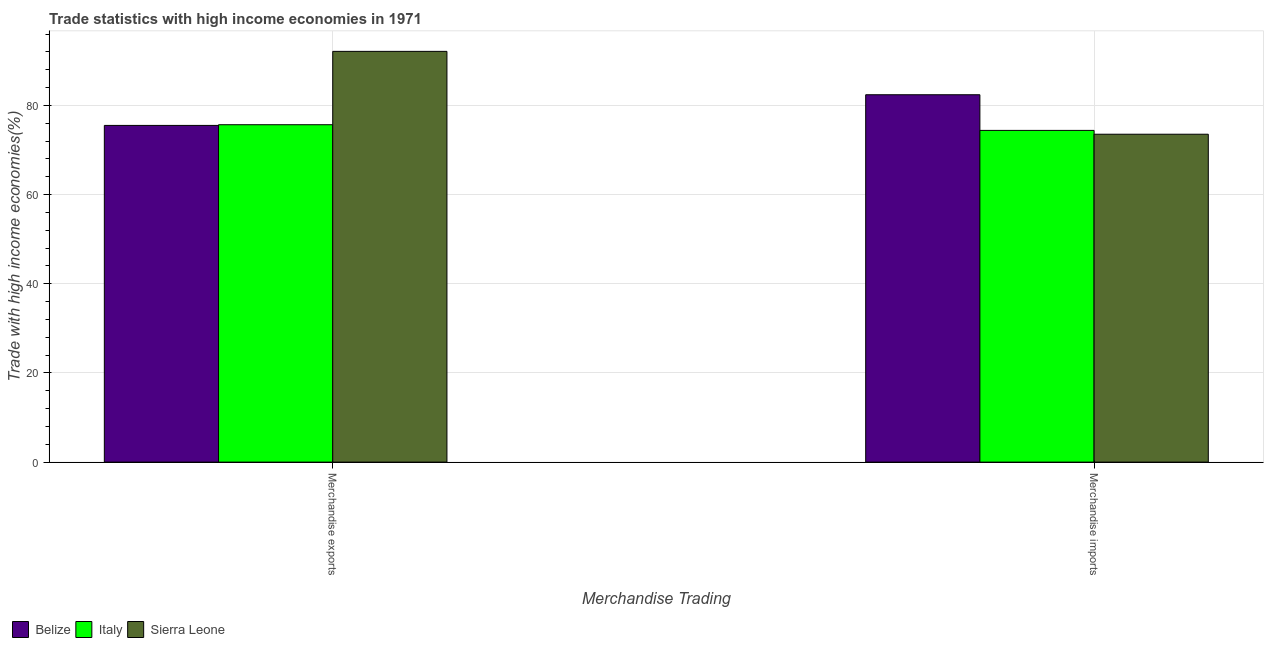Are the number of bars per tick equal to the number of legend labels?
Keep it short and to the point. Yes. How many bars are there on the 1st tick from the left?
Offer a terse response. 3. What is the label of the 2nd group of bars from the left?
Keep it short and to the point. Merchandise imports. What is the merchandise imports in Belize?
Your answer should be very brief. 82.4. Across all countries, what is the maximum merchandise imports?
Offer a very short reply. 82.4. Across all countries, what is the minimum merchandise exports?
Provide a succinct answer. 75.53. In which country was the merchandise imports maximum?
Offer a terse response. Belize. In which country was the merchandise imports minimum?
Provide a short and direct response. Sierra Leone. What is the total merchandise exports in the graph?
Ensure brevity in your answer.  243.34. What is the difference between the merchandise imports in Belize and that in Italy?
Your answer should be compact. 8. What is the difference between the merchandise exports in Italy and the merchandise imports in Sierra Leone?
Give a very brief answer. 2.13. What is the average merchandise imports per country?
Offer a very short reply. 76.79. What is the difference between the merchandise exports and merchandise imports in Sierra Leone?
Keep it short and to the point. 18.59. What is the ratio of the merchandise imports in Sierra Leone to that in Belize?
Your answer should be very brief. 0.89. Is the merchandise imports in Sierra Leone less than that in Belize?
Provide a succinct answer. Yes. In how many countries, is the merchandise exports greater than the average merchandise exports taken over all countries?
Your response must be concise. 1. What does the 1st bar from the left in Merchandise imports represents?
Provide a short and direct response. Belize. What does the 3rd bar from the right in Merchandise imports represents?
Keep it short and to the point. Belize. How many bars are there?
Give a very brief answer. 6. Where does the legend appear in the graph?
Your answer should be very brief. Bottom left. How are the legend labels stacked?
Make the answer very short. Horizontal. What is the title of the graph?
Ensure brevity in your answer.  Trade statistics with high income economies in 1971. Does "Andorra" appear as one of the legend labels in the graph?
Your answer should be very brief. No. What is the label or title of the X-axis?
Offer a very short reply. Merchandise Trading. What is the label or title of the Y-axis?
Your answer should be compact. Trade with high income economies(%). What is the Trade with high income economies(%) in Belize in Merchandise exports?
Make the answer very short. 75.53. What is the Trade with high income economies(%) of Italy in Merchandise exports?
Your answer should be compact. 75.68. What is the Trade with high income economies(%) in Sierra Leone in Merchandise exports?
Your answer should be compact. 92.14. What is the Trade with high income economies(%) of Belize in Merchandise imports?
Your answer should be very brief. 82.4. What is the Trade with high income economies(%) in Italy in Merchandise imports?
Offer a very short reply. 74.41. What is the Trade with high income economies(%) in Sierra Leone in Merchandise imports?
Make the answer very short. 73.55. Across all Merchandise Trading, what is the maximum Trade with high income economies(%) in Belize?
Give a very brief answer. 82.4. Across all Merchandise Trading, what is the maximum Trade with high income economies(%) in Italy?
Make the answer very short. 75.68. Across all Merchandise Trading, what is the maximum Trade with high income economies(%) of Sierra Leone?
Offer a terse response. 92.14. Across all Merchandise Trading, what is the minimum Trade with high income economies(%) in Belize?
Your response must be concise. 75.53. Across all Merchandise Trading, what is the minimum Trade with high income economies(%) in Italy?
Your response must be concise. 74.41. Across all Merchandise Trading, what is the minimum Trade with high income economies(%) in Sierra Leone?
Keep it short and to the point. 73.55. What is the total Trade with high income economies(%) in Belize in the graph?
Make the answer very short. 157.93. What is the total Trade with high income economies(%) in Italy in the graph?
Give a very brief answer. 150.09. What is the total Trade with high income economies(%) of Sierra Leone in the graph?
Make the answer very short. 165.69. What is the difference between the Trade with high income economies(%) in Belize in Merchandise exports and that in Merchandise imports?
Offer a terse response. -6.88. What is the difference between the Trade with high income economies(%) of Italy in Merchandise exports and that in Merchandise imports?
Make the answer very short. 1.27. What is the difference between the Trade with high income economies(%) in Sierra Leone in Merchandise exports and that in Merchandise imports?
Keep it short and to the point. 18.59. What is the difference between the Trade with high income economies(%) of Belize in Merchandise exports and the Trade with high income economies(%) of Italy in Merchandise imports?
Offer a terse response. 1.12. What is the difference between the Trade with high income economies(%) in Belize in Merchandise exports and the Trade with high income economies(%) in Sierra Leone in Merchandise imports?
Give a very brief answer. 1.98. What is the difference between the Trade with high income economies(%) in Italy in Merchandise exports and the Trade with high income economies(%) in Sierra Leone in Merchandise imports?
Keep it short and to the point. 2.13. What is the average Trade with high income economies(%) of Belize per Merchandise Trading?
Ensure brevity in your answer.  78.97. What is the average Trade with high income economies(%) in Italy per Merchandise Trading?
Make the answer very short. 75.04. What is the average Trade with high income economies(%) of Sierra Leone per Merchandise Trading?
Provide a succinct answer. 82.84. What is the difference between the Trade with high income economies(%) in Belize and Trade with high income economies(%) in Italy in Merchandise exports?
Provide a short and direct response. -0.15. What is the difference between the Trade with high income economies(%) of Belize and Trade with high income economies(%) of Sierra Leone in Merchandise exports?
Make the answer very short. -16.61. What is the difference between the Trade with high income economies(%) of Italy and Trade with high income economies(%) of Sierra Leone in Merchandise exports?
Give a very brief answer. -16.46. What is the difference between the Trade with high income economies(%) in Belize and Trade with high income economies(%) in Italy in Merchandise imports?
Ensure brevity in your answer.  8. What is the difference between the Trade with high income economies(%) in Belize and Trade with high income economies(%) in Sierra Leone in Merchandise imports?
Your answer should be very brief. 8.85. What is the difference between the Trade with high income economies(%) of Italy and Trade with high income economies(%) of Sierra Leone in Merchandise imports?
Your answer should be compact. 0.86. What is the ratio of the Trade with high income economies(%) in Belize in Merchandise exports to that in Merchandise imports?
Offer a very short reply. 0.92. What is the ratio of the Trade with high income economies(%) in Italy in Merchandise exports to that in Merchandise imports?
Offer a terse response. 1.02. What is the ratio of the Trade with high income economies(%) of Sierra Leone in Merchandise exports to that in Merchandise imports?
Your answer should be compact. 1.25. What is the difference between the highest and the second highest Trade with high income economies(%) of Belize?
Offer a terse response. 6.88. What is the difference between the highest and the second highest Trade with high income economies(%) of Italy?
Your answer should be compact. 1.27. What is the difference between the highest and the second highest Trade with high income economies(%) in Sierra Leone?
Provide a short and direct response. 18.59. What is the difference between the highest and the lowest Trade with high income economies(%) in Belize?
Keep it short and to the point. 6.88. What is the difference between the highest and the lowest Trade with high income economies(%) of Italy?
Your response must be concise. 1.27. What is the difference between the highest and the lowest Trade with high income economies(%) of Sierra Leone?
Ensure brevity in your answer.  18.59. 